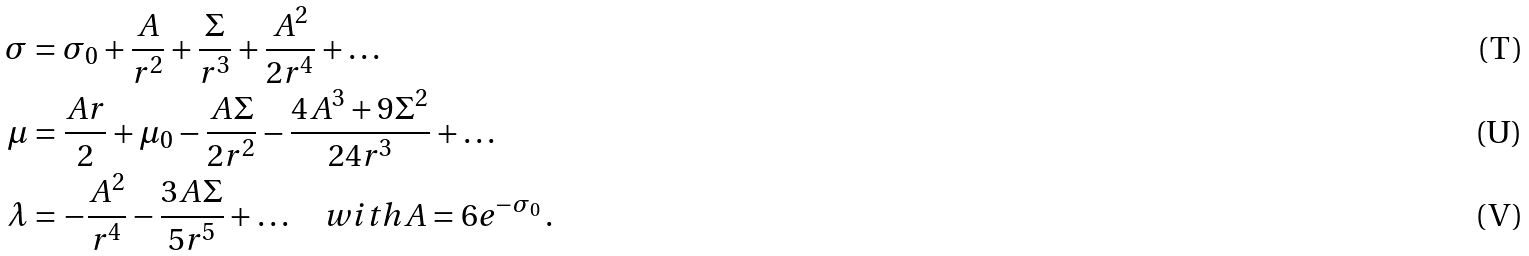Convert formula to latex. <formula><loc_0><loc_0><loc_500><loc_500>\sigma & = \sigma _ { 0 } + \frac { A } { r ^ { 2 } } + \frac { \Sigma } { r ^ { 3 } } + \frac { A ^ { 2 } } { 2 r ^ { 4 } } + \dots \\ \mu & = \frac { A r } { 2 } + \mu _ { 0 } - \frac { A \Sigma } { 2 r ^ { 2 } } - \frac { 4 A ^ { 3 } + 9 \Sigma ^ { 2 } } { 2 4 r ^ { 3 } } + \dots \\ \lambda & = - \frac { A ^ { 2 } } { r ^ { 4 } } - \frac { 3 A \Sigma } { 5 r ^ { 5 } } + \dots \quad w i t h A = 6 e ^ { - \sigma _ { 0 } } \, .</formula> 